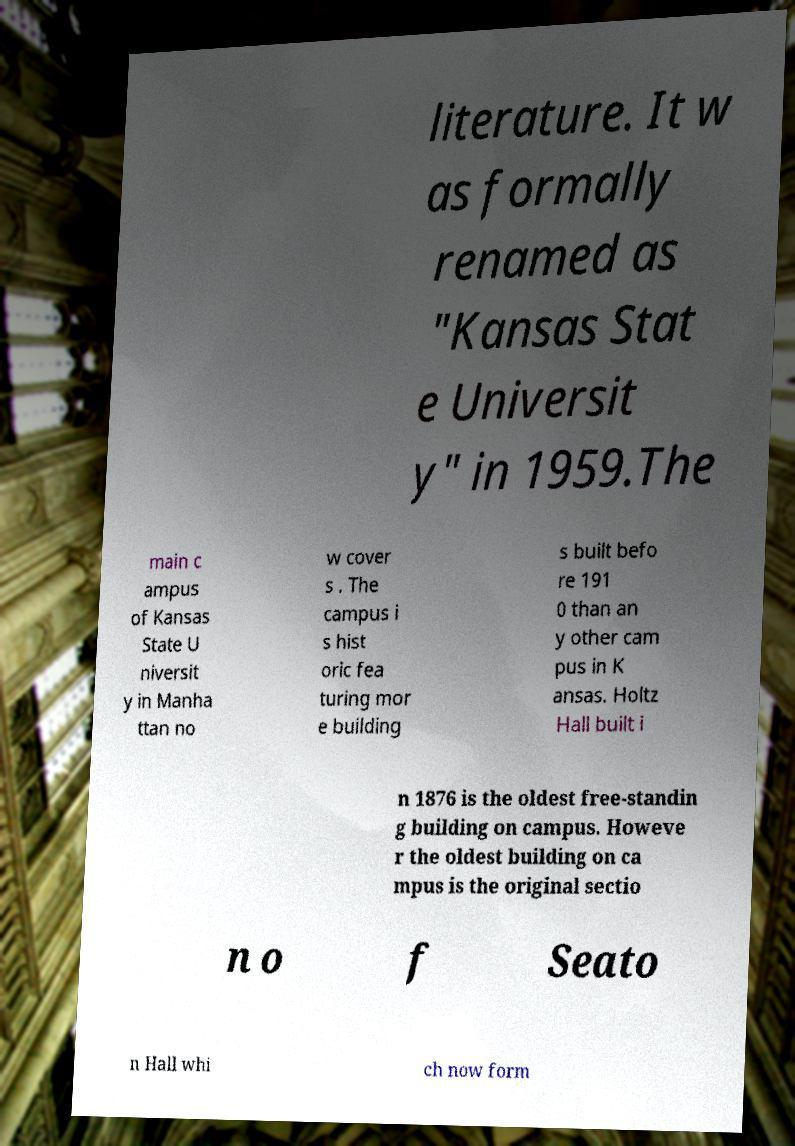What messages or text are displayed in this image? I need them in a readable, typed format. literature. It w as formally renamed as "Kansas Stat e Universit y" in 1959.The main c ampus of Kansas State U niversit y in Manha ttan no w cover s . The campus i s hist oric fea turing mor e building s built befo re 191 0 than an y other cam pus in K ansas. Holtz Hall built i n 1876 is the oldest free-standin g building on campus. Howeve r the oldest building on ca mpus is the original sectio n o f Seato n Hall whi ch now form 